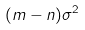<formula> <loc_0><loc_0><loc_500><loc_500>( m - n ) \sigma ^ { 2 }</formula> 